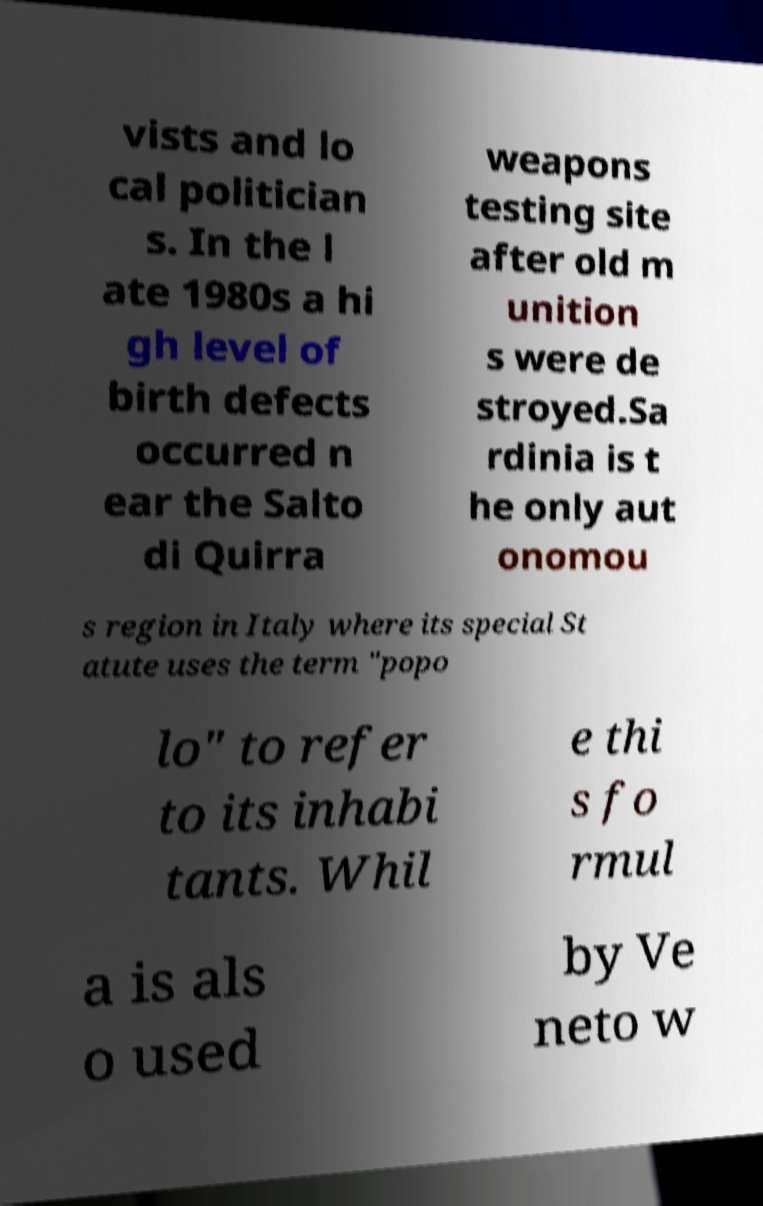Can you read and provide the text displayed in the image?This photo seems to have some interesting text. Can you extract and type it out for me? vists and lo cal politician s. In the l ate 1980s a hi gh level of birth defects occurred n ear the Salto di Quirra weapons testing site after old m unition s were de stroyed.Sa rdinia is t he only aut onomou s region in Italy where its special St atute uses the term "popo lo" to refer to its inhabi tants. Whil e thi s fo rmul a is als o used by Ve neto w 